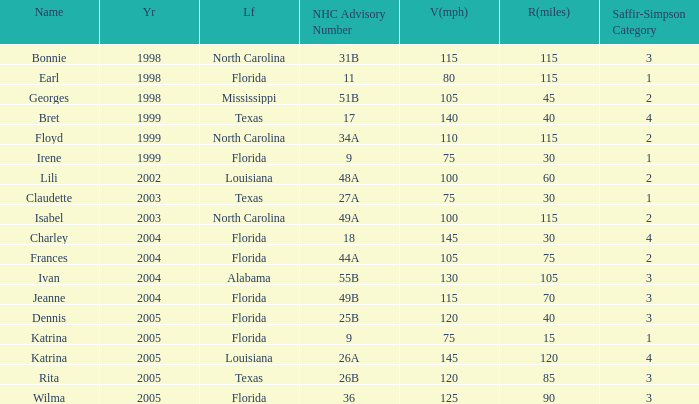What was the lowest V(mph) for a Saffir-Simpson of 4 in 2005? 145.0. Parse the table in full. {'header': ['Name', 'Yr', 'Lf', 'NHC Advisory Number', 'V(mph)', 'R(miles)', 'Saffir-Simpson Category'], 'rows': [['Bonnie', '1998', 'North Carolina', '31B', '115', '115', '3'], ['Earl', '1998', 'Florida', '11', '80', '115', '1'], ['Georges', '1998', 'Mississippi', '51B', '105', '45', '2'], ['Bret', '1999', 'Texas', '17', '140', '40', '4'], ['Floyd', '1999', 'North Carolina', '34A', '110', '115', '2'], ['Irene', '1999', 'Florida', '9', '75', '30', '1'], ['Lili', '2002', 'Louisiana', '48A', '100', '60', '2'], ['Claudette', '2003', 'Texas', '27A', '75', '30', '1'], ['Isabel', '2003', 'North Carolina', '49A', '100', '115', '2'], ['Charley', '2004', 'Florida', '18', '145', '30', '4'], ['Frances', '2004', 'Florida', '44A', '105', '75', '2'], ['Ivan', '2004', 'Alabama', '55B', '130', '105', '3'], ['Jeanne', '2004', 'Florida', '49B', '115', '70', '3'], ['Dennis', '2005', 'Florida', '25B', '120', '40', '3'], ['Katrina', '2005', 'Florida', '9', '75', '15', '1'], ['Katrina', '2005', 'Louisiana', '26A', '145', '120', '4'], ['Rita', '2005', 'Texas', '26B', '120', '85', '3'], ['Wilma', '2005', 'Florida', '36', '125', '90', '3']]} 